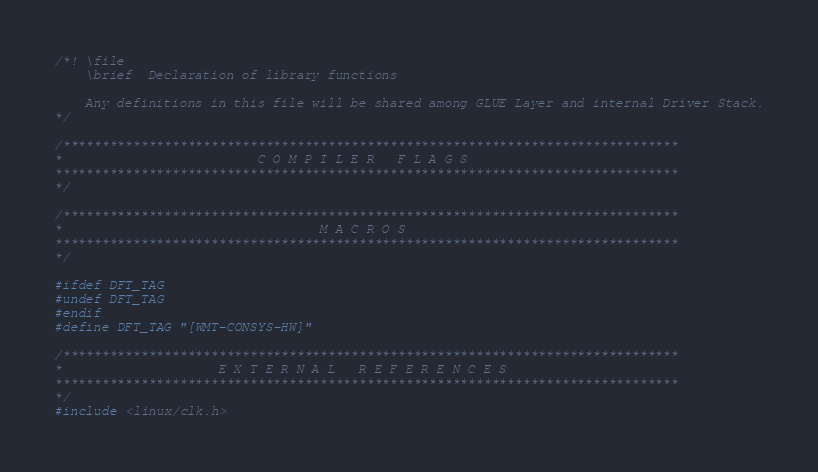Convert code to text. <code><loc_0><loc_0><loc_500><loc_500><_C_>/*! \file
    \brief  Declaration of library functions

    Any definitions in this file will be shared among GLUE Layer and internal Driver Stack.
*/

/*******************************************************************************
*                         C O M P I L E R   F L A G S
********************************************************************************
*/

/*******************************************************************************
*                                 M A C R O S
********************************************************************************
*/

#ifdef DFT_TAG
#undef DFT_TAG
#endif
#define DFT_TAG "[WMT-CONSYS-HW]"

/*******************************************************************************
*                    E X T E R N A L   R E F E R E N C E S
********************************************************************************
*/
#include <linux/clk.h></code> 